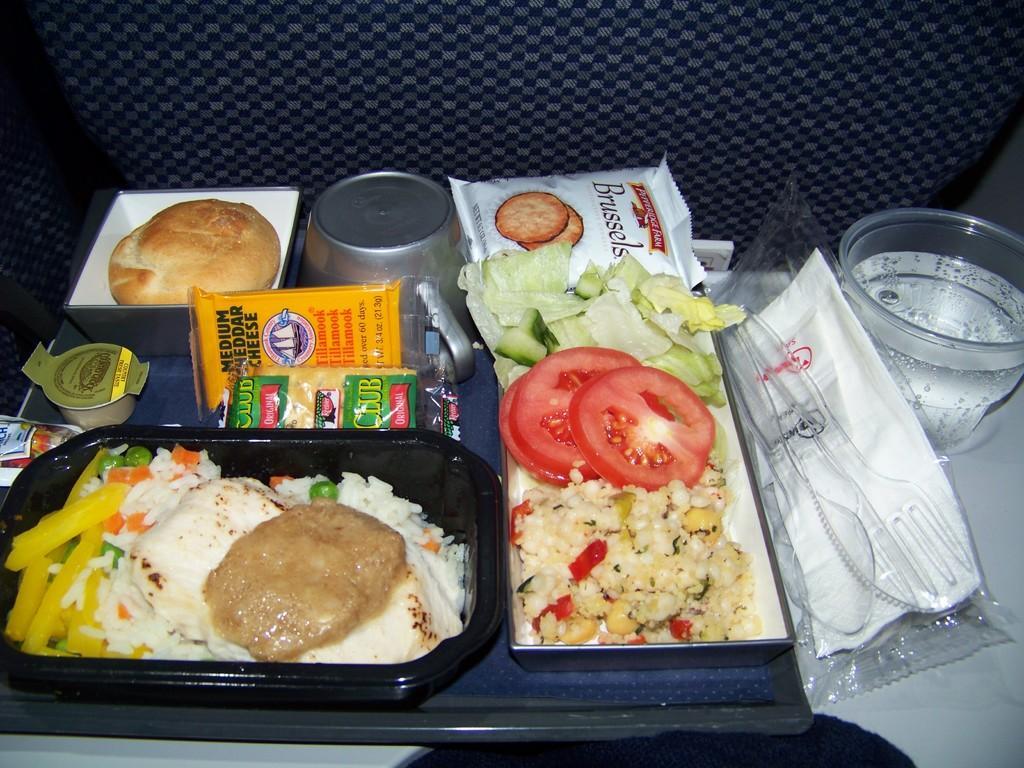Can you describe this image briefly? In this image we can see some food placed on the plate. We can see a plate is placed on the chair. There is a drink and few objects placed on the chair. 